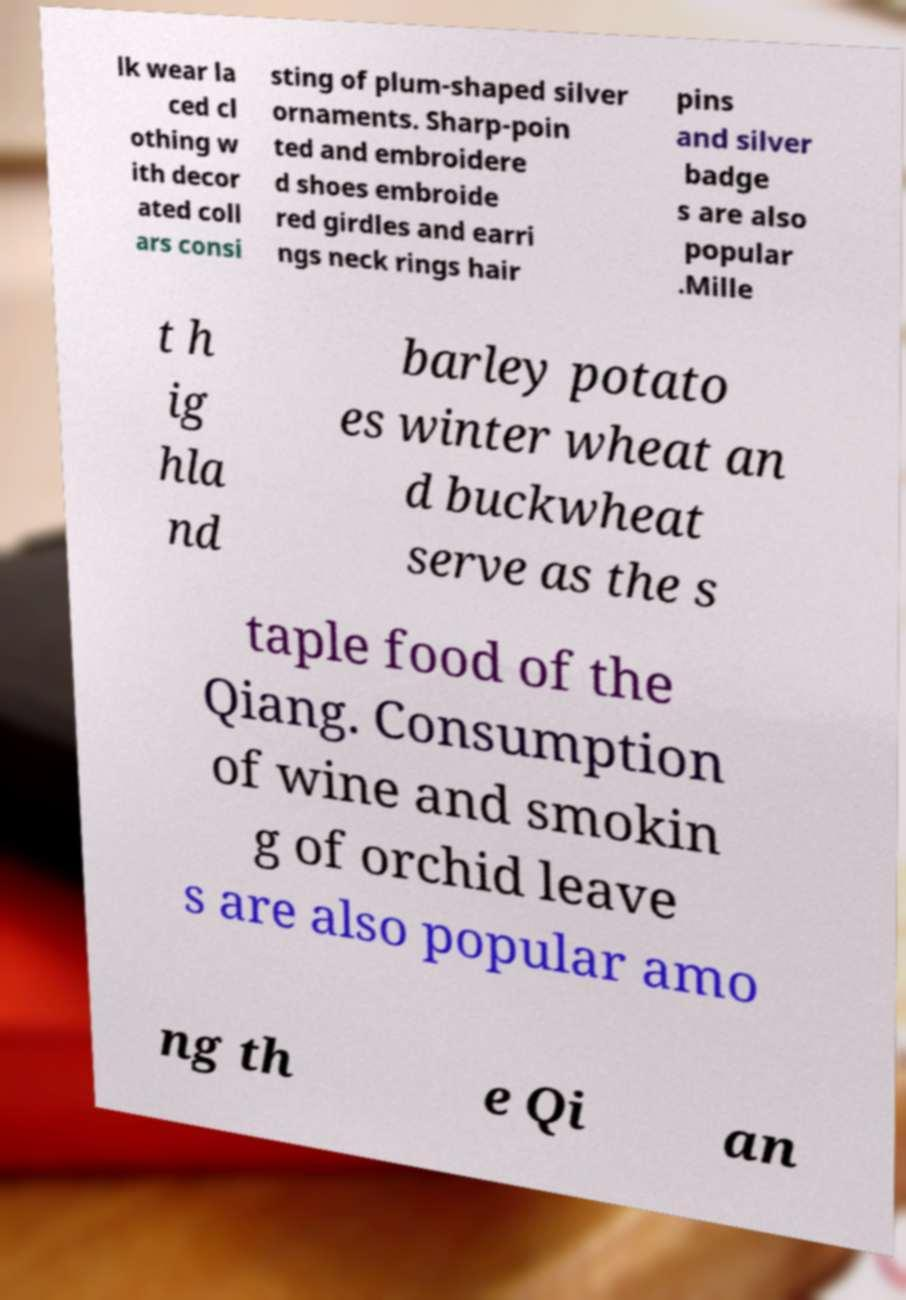What messages or text are displayed in this image? I need them in a readable, typed format. lk wear la ced cl othing w ith decor ated coll ars consi sting of plum-shaped silver ornaments. Sharp-poin ted and embroidere d shoes embroide red girdles and earri ngs neck rings hair pins and silver badge s are also popular .Mille t h ig hla nd barley potato es winter wheat an d buckwheat serve as the s taple food of the Qiang. Consumption of wine and smokin g of orchid leave s are also popular amo ng th e Qi an 